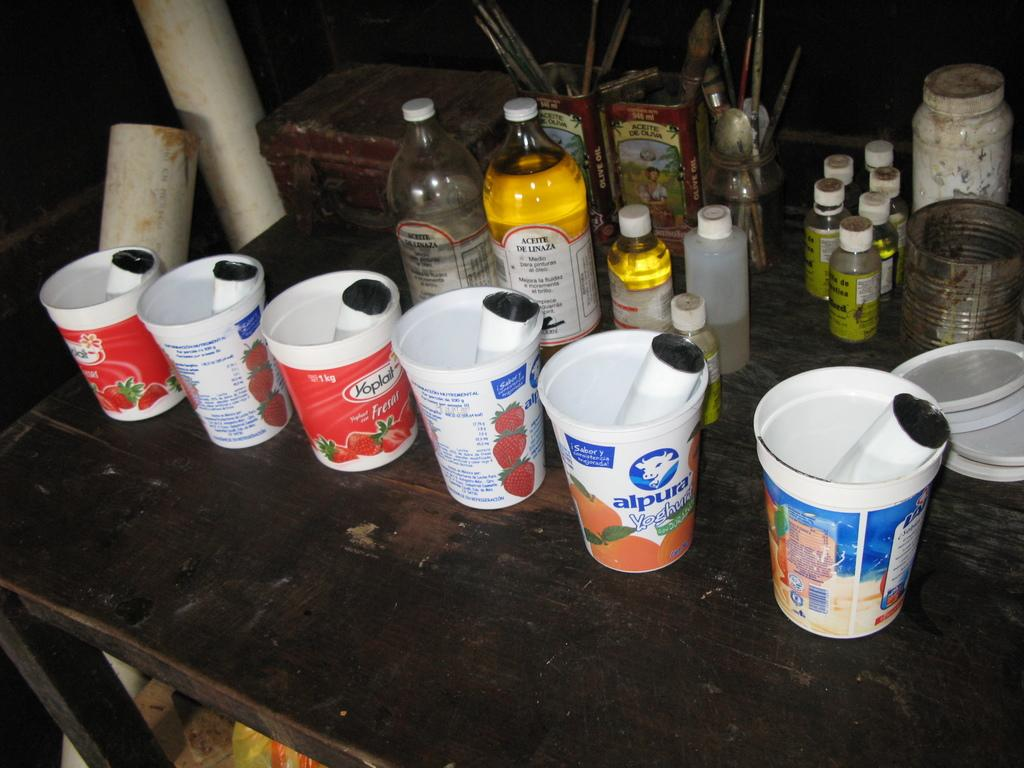<image>
Offer a succinct explanation of the picture presented. an alpura cup that is on top of the desk 